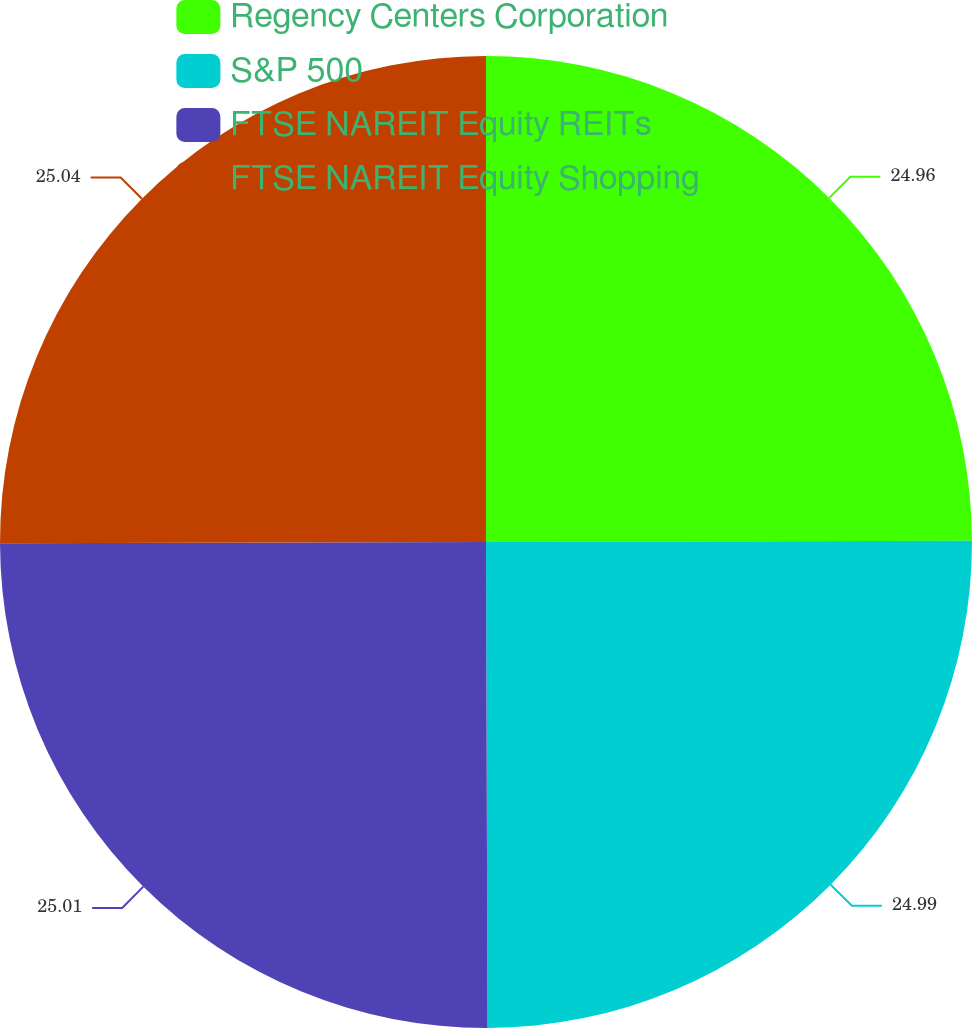<chart> <loc_0><loc_0><loc_500><loc_500><pie_chart><fcel>Regency Centers Corporation<fcel>S&P 500<fcel>FTSE NAREIT Equity REITs<fcel>FTSE NAREIT Equity Shopping<nl><fcel>24.96%<fcel>24.99%<fcel>25.01%<fcel>25.04%<nl></chart> 